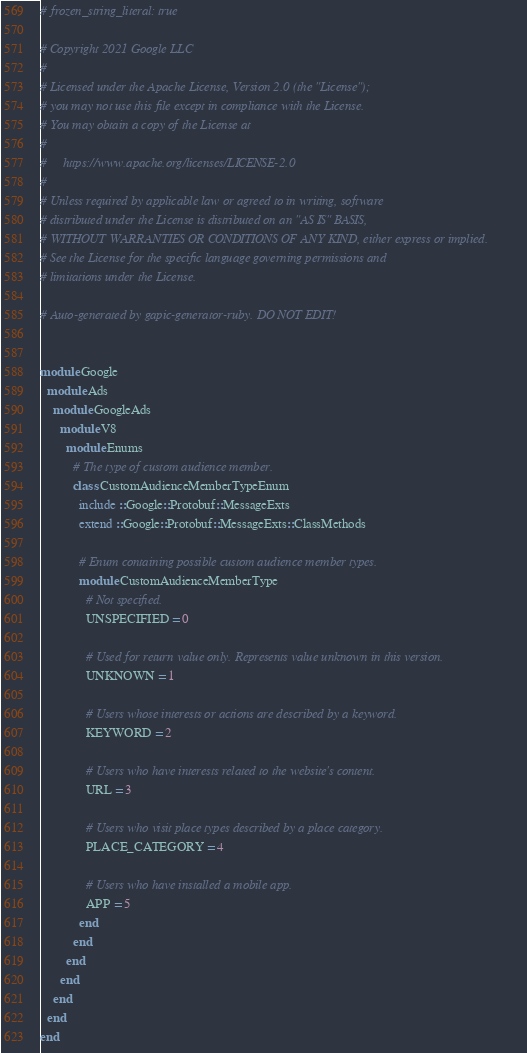<code> <loc_0><loc_0><loc_500><loc_500><_Ruby_># frozen_string_literal: true

# Copyright 2021 Google LLC
#
# Licensed under the Apache License, Version 2.0 (the "License");
# you may not use this file except in compliance with the License.
# You may obtain a copy of the License at
#
#     https://www.apache.org/licenses/LICENSE-2.0
#
# Unless required by applicable law or agreed to in writing, software
# distributed under the License is distributed on an "AS IS" BASIS,
# WITHOUT WARRANTIES OR CONDITIONS OF ANY KIND, either express or implied.
# See the License for the specific language governing permissions and
# limitations under the License.

# Auto-generated by gapic-generator-ruby. DO NOT EDIT!


module Google
  module Ads
    module GoogleAds
      module V8
        module Enums
          # The type of custom audience member.
          class CustomAudienceMemberTypeEnum
            include ::Google::Protobuf::MessageExts
            extend ::Google::Protobuf::MessageExts::ClassMethods

            # Enum containing possible custom audience member types.
            module CustomAudienceMemberType
              # Not specified.
              UNSPECIFIED = 0

              # Used for return value only. Represents value unknown in this version.
              UNKNOWN = 1

              # Users whose interests or actions are described by a keyword.
              KEYWORD = 2

              # Users who have interests related to the website's content.
              URL = 3

              # Users who visit place types described by a place category.
              PLACE_CATEGORY = 4

              # Users who have installed a mobile app.
              APP = 5
            end
          end
        end
      end
    end
  end
end
</code> 